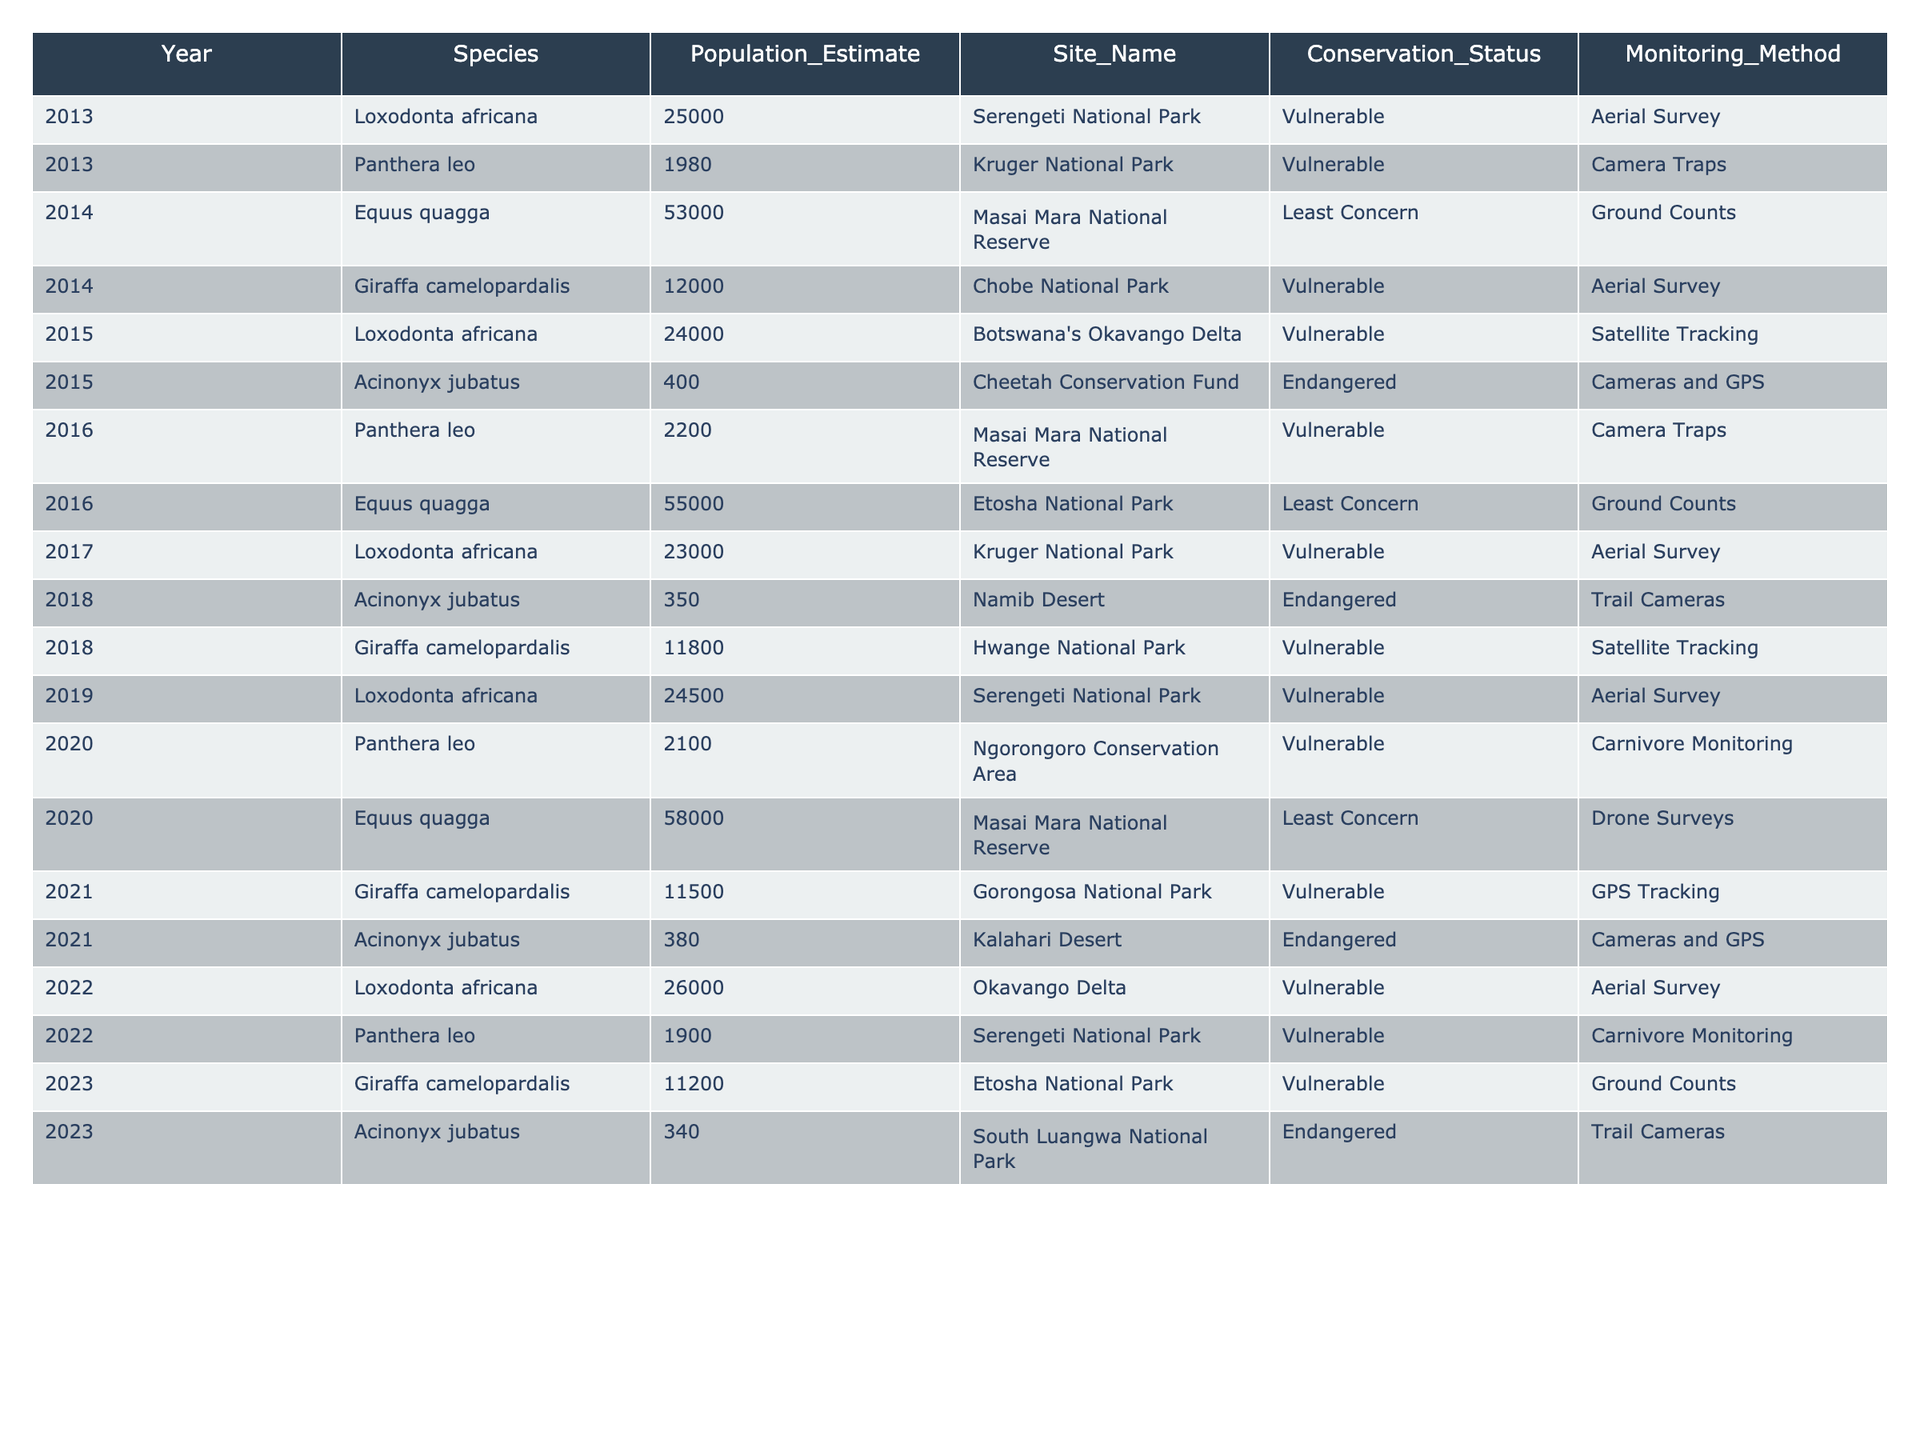What is the highest population estimate recorded for Loxodonta africana? The highest estimation for Loxodonta africana can be found by looking through the "Population_Estimate" column for this species. The values are 25000 (2013), 24000 (2015), 23000 (2017), 24500 (2019), and 26000 (2022). The maximum value is 26000 in 2022.
Answer: 26000 In which year was the population of Panthera leo lowest? To find the lowest population of Panthera leo, I will look at the years and their corresponding population estimates: 1980 (2013), 2200 (2016), 2100 (2020), and 1900 (2022). The lowest population is 1900 in 2022.
Answer: 2022 How many conservation statuses are represented in the table? The conservation statuses listed are Vulnerable and Endangered. Counting distinct statuses gives a total of 2 different statuses.
Answer: 2 What is the average population estimate for Equus quagga over the years? The population estimates for Equus quagga are 53000 (2014), 55000 (2016), and 58000 (2020). Adding them gives 53000 + 55000 + 58000 = 166000. Dividing this sum by the number of entries (3) gives an average of 166000 / 3 = 55333.33, rounded to 55333.
Answer: 55333 Was the population of Giraffa camelopardalis consistently declining from 2014 to 2023? The population estimates for Giraffa camelopardalis are 12000 (2014), 11800 (2018), 11500 (2021), and 11200 (2023). Since all values are decreasing, it confirms a consistent decline over these years.
Answer: Yes Which site had the highest population estimate for Loxodonta africana and what was that estimate? The site with the highest population estimate for Loxodonta africana is Okavango Delta in 2022 with a population of 26000. Other estimates are less than this value.
Answer: Okavango Delta, 26000 How does the monitoring method vary for Acinonyx jubatus across the years? Acinonyx jubatus was monitored using different methods: Cameras and GPS (2015), Trail Cameras (2018), and Cameras and GPS (2021). The variation shows two different methods used across the years.
Answer: Two methods What is the total population estimate for Loxodonta africana over the decade? The population estimates for Loxodonta africana are 25000 (2013), 24000 (2015), 23000 (2017), 24500 (2019), and 26000 (2022). Summing these values gives 25000 + 24000 + 23000 + 24500 + 26000 = 122500.
Answer: 122500 Is there any year where the population estimate for Giraffa camelopardalis was above 12000? The estimates for Giraffa camelopardalis in the relevant years are 12000 (2014), 11800 (2018), 11500 (2021), and 11200 (2023). Since all values from 2018 onwards are below 12000, there is only one year 2014 where it was exactly 12000.
Answer: No What species had the lowest monitoring values across the years? In reviewing the table, the lowest monitoring values for species are Acinonyx jubatus with populations recorded as 400 (2015), 350 (2018), and 380 (2021). The minimum is 350 in 2018.
Answer: Acinonyx jubatus, 350 